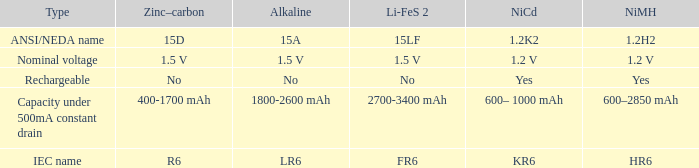What is NiCd, when Type is "Capacity under 500mA constant Drain"? 600– 1000 mAh. 